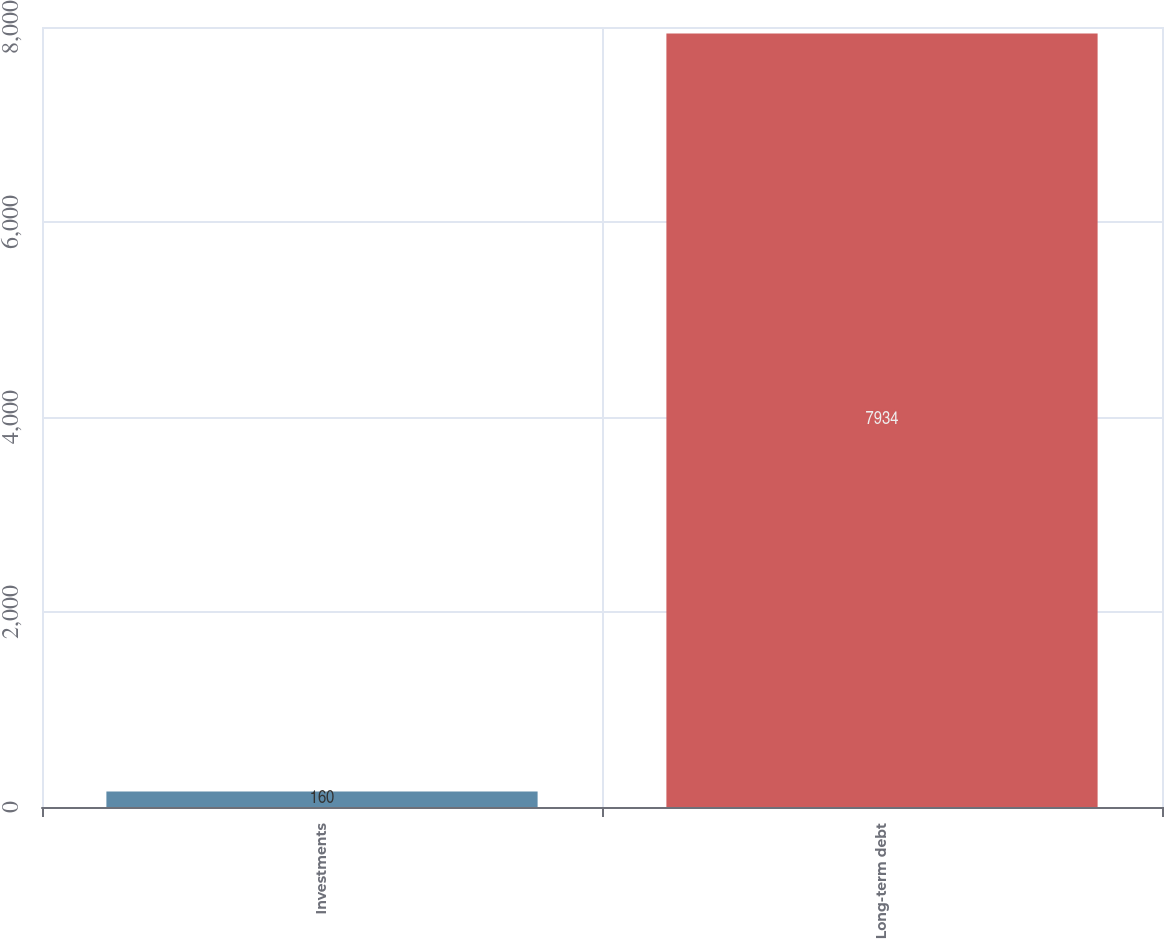<chart> <loc_0><loc_0><loc_500><loc_500><bar_chart><fcel>Investments<fcel>Long-term debt<nl><fcel>160<fcel>7934<nl></chart> 